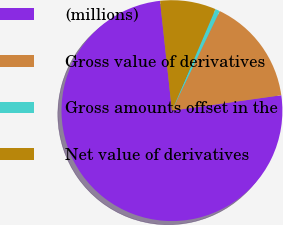<chart> <loc_0><loc_0><loc_500><loc_500><pie_chart><fcel>(millions)<fcel>Gross value of derivatives<fcel>Gross amounts offset in the<fcel>Net value of derivatives<nl><fcel>75.51%<fcel>15.65%<fcel>0.68%<fcel>8.16%<nl></chart> 